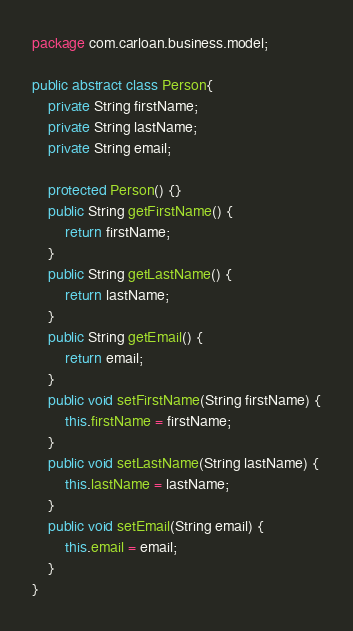Convert code to text. <code><loc_0><loc_0><loc_500><loc_500><_Java_>package com.carloan.business.model;

public abstract class Person{
	private String firstName;
	private String lastName;
	private String email;
	
	protected Person() {}
	public String getFirstName() {
		return firstName;
	}
	public String getLastName() {
		return lastName;
	}
	public String getEmail() {
		return email;
	}
	public void setFirstName(String firstName) {
		this.firstName = firstName;
	}
	public void setLastName(String lastName) {
		this.lastName = lastName;
	}
	public void setEmail(String email) {
		this.email = email;
	}
}
</code> 